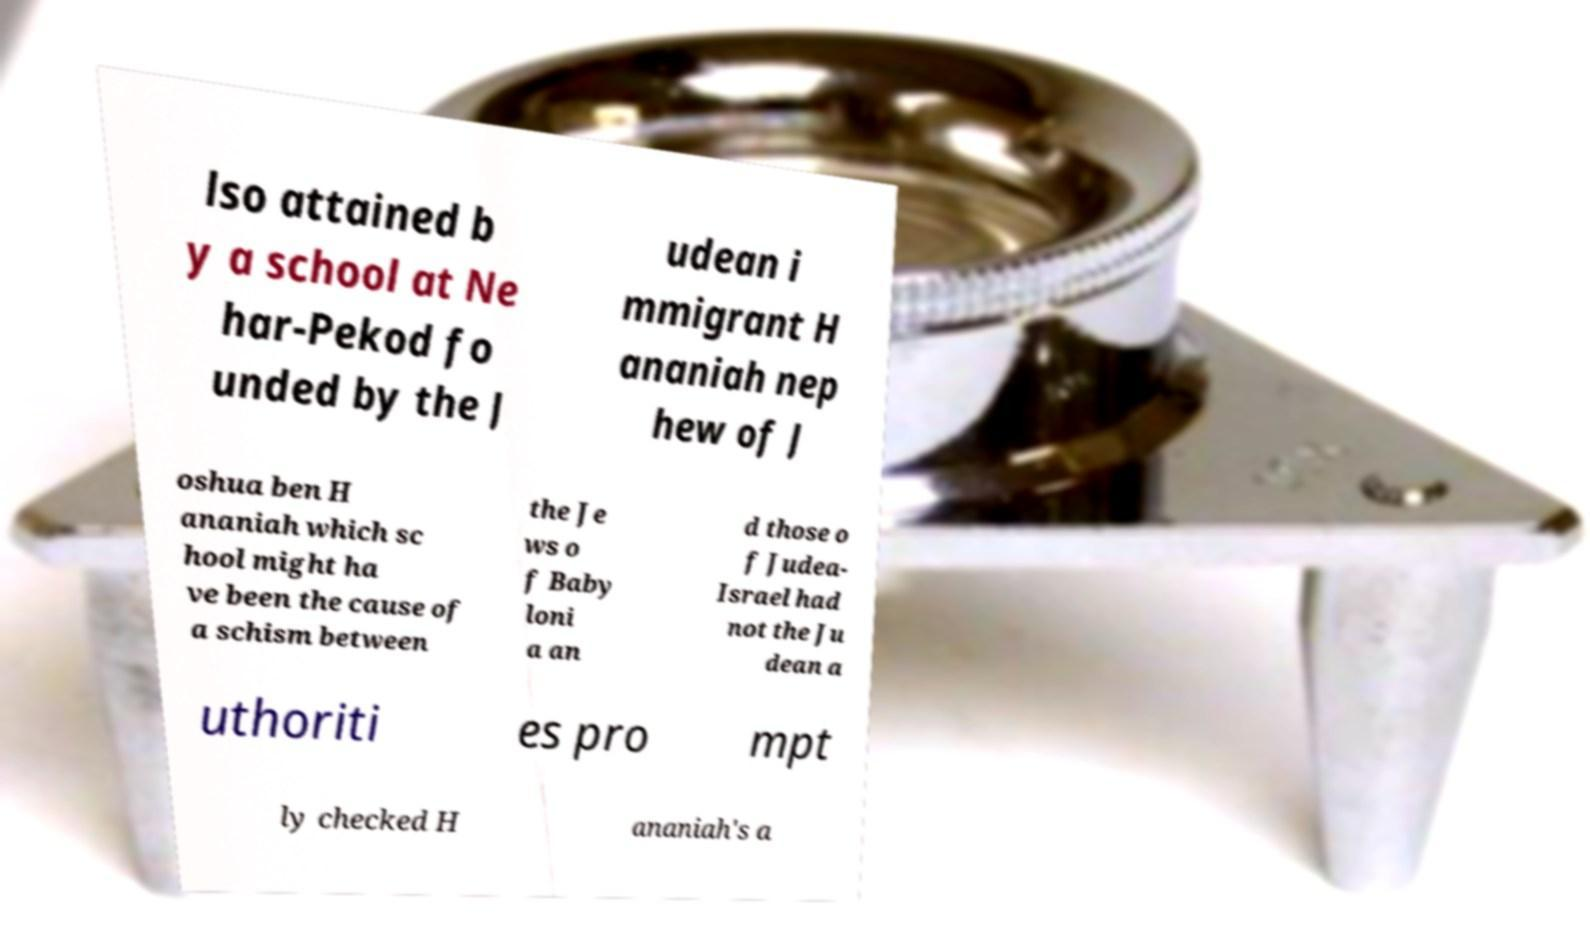Please read and relay the text visible in this image. What does it say? lso attained b y a school at Ne har-Pekod fo unded by the J udean i mmigrant H ananiah nep hew of J oshua ben H ananiah which sc hool might ha ve been the cause of a schism between the Je ws o f Baby loni a an d those o f Judea- Israel had not the Ju dean a uthoriti es pro mpt ly checked H ananiah's a 